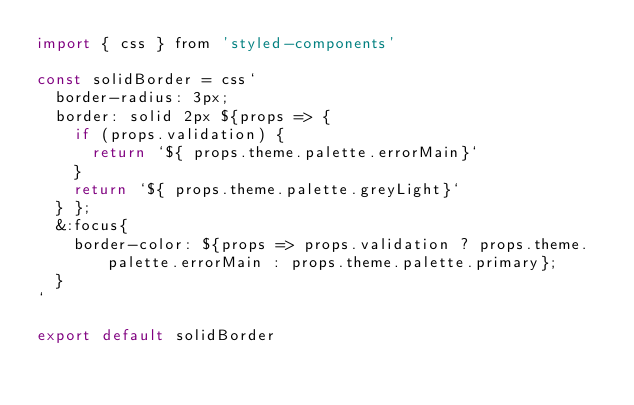Convert code to text. <code><loc_0><loc_0><loc_500><loc_500><_JavaScript_>import { css } from 'styled-components'

const solidBorder = css`
  border-radius: 3px;
  border: solid 2px ${props => {
    if (props.validation) {
      return `${ props.theme.palette.errorMain}`
    }
    return `${ props.theme.palette.greyLight}`
  } };
  &:focus{
    border-color: ${props => props.validation ? props.theme.palette.errorMain : props.theme.palette.primary};
  }
`

export default solidBorder
</code> 